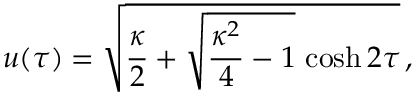Convert formula to latex. <formula><loc_0><loc_0><loc_500><loc_500>u ( \tau ) = \sqrt { { \frac { \kappa } { 2 } } + \sqrt { { \frac { \kappa ^ { 2 } } { 4 } } - 1 } \, \cosh 2 \tau } \, ,</formula> 